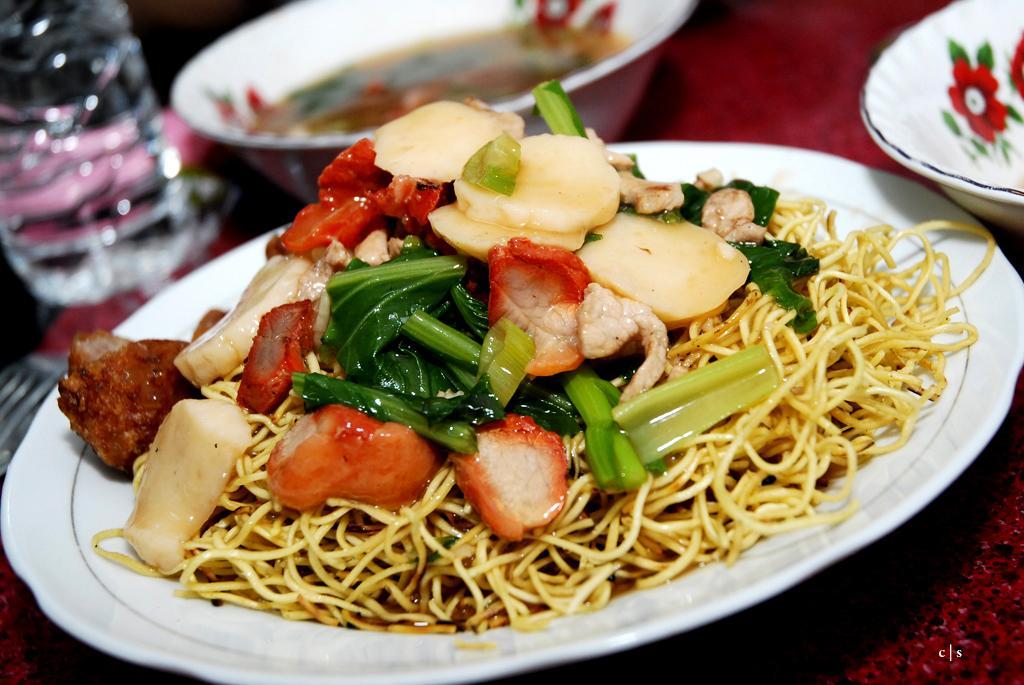Could you give a brief overview of what you see in this image? In this picture we can see a table, there is a plate, two bowls, a water bottle, a fork present on the table, we can see noodles and some food present on this plate, there is some soup in this bowl. 